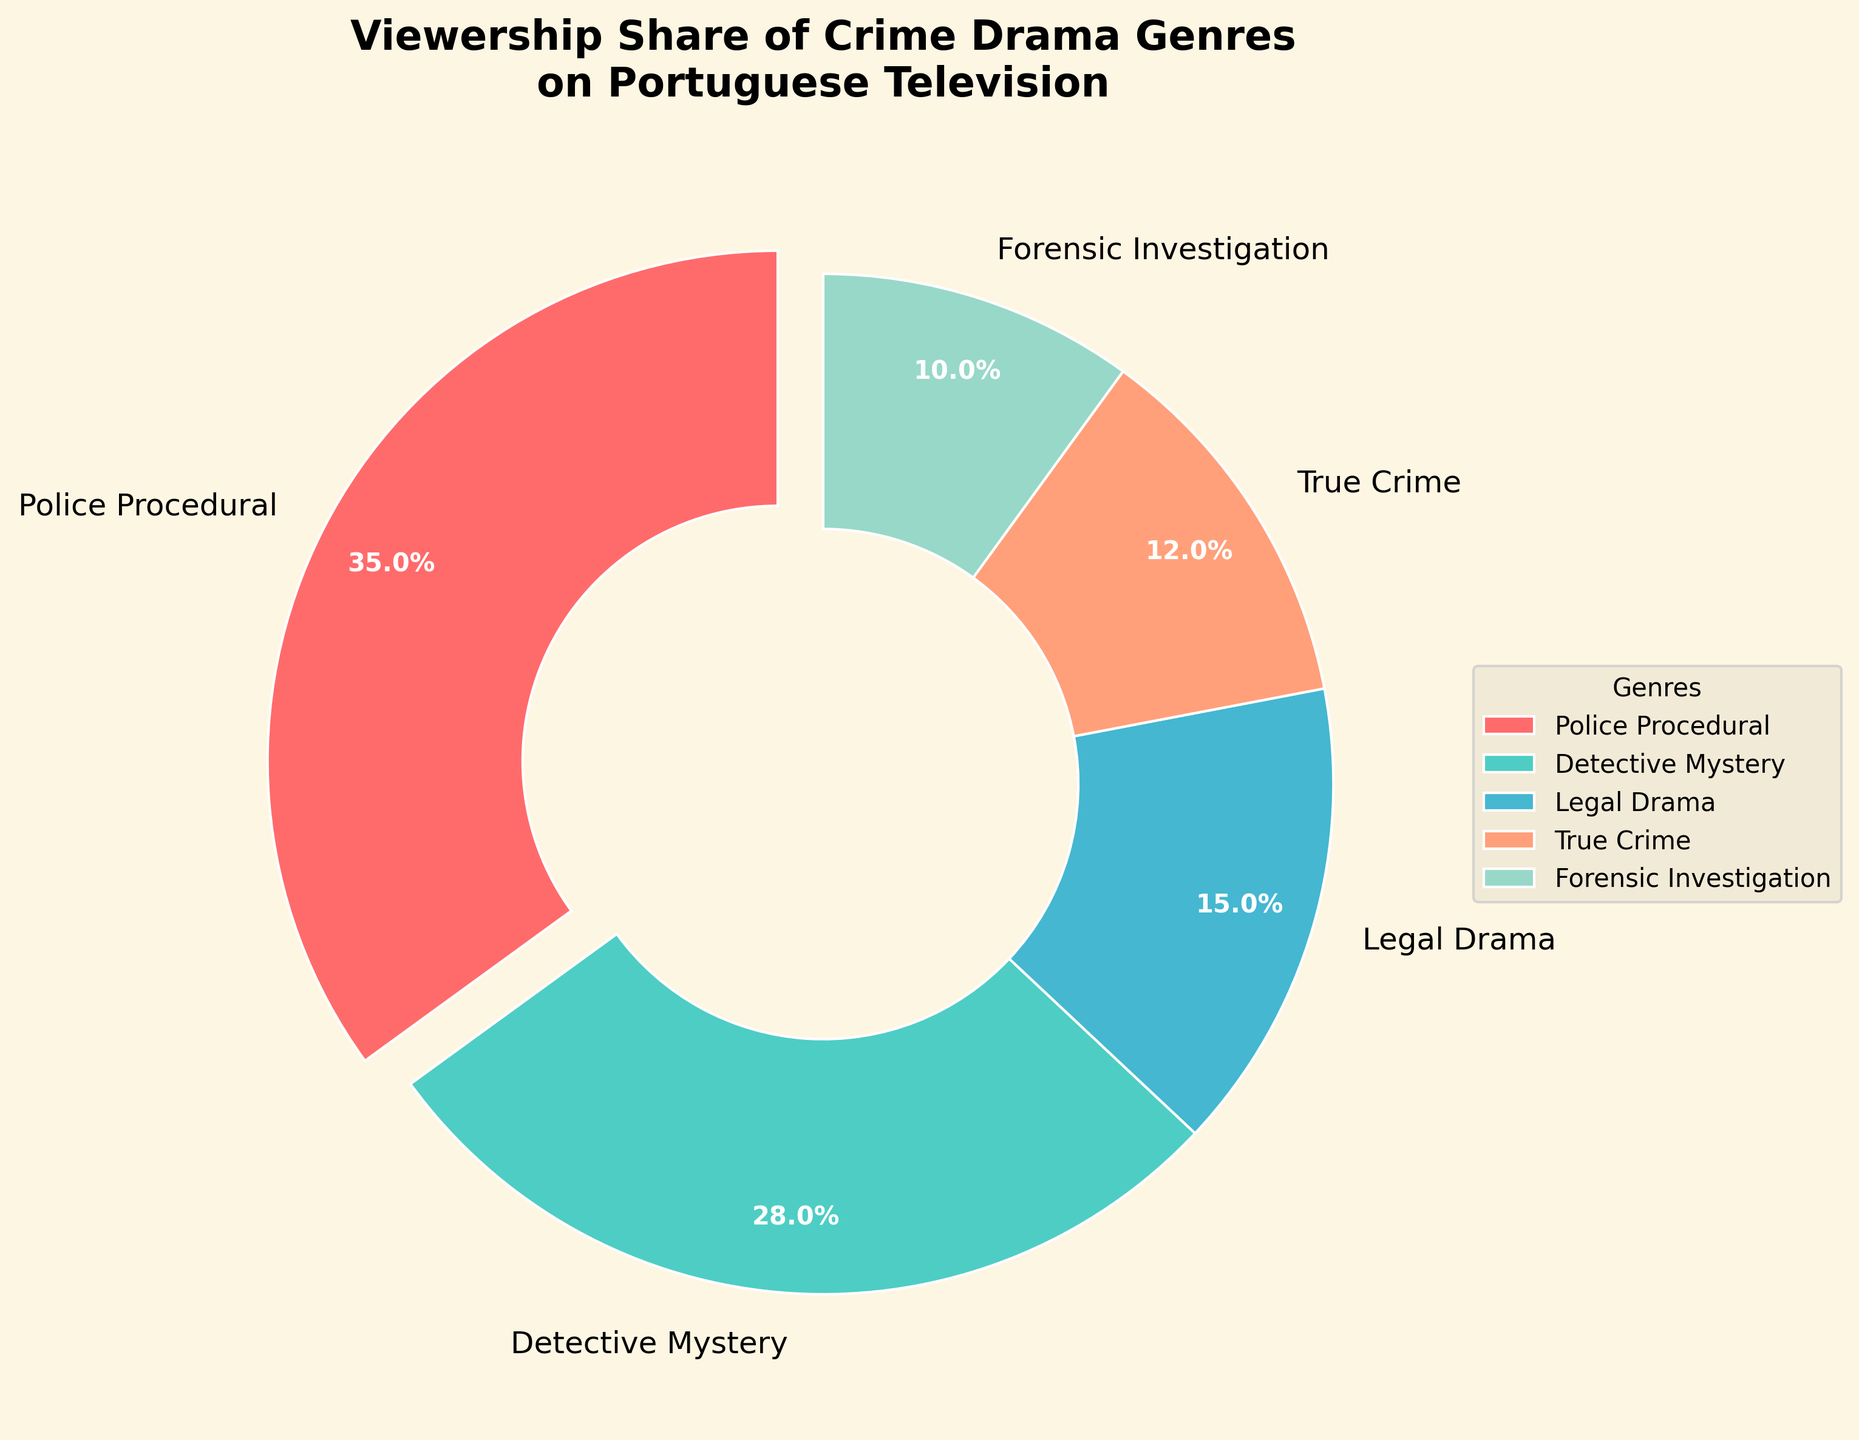what is the title of the plot? The title of the plot is stated at the top of the figure. It provides an overview of what the plot represents. The title is "Viewership Share of Crime Drama Genres on Portuguese Television".
Answer: Viewership Share of Crime Drama Genres on Portuguese Television Which genre has the highest viewership share? By examining the pie chart, the segment with the largest portion corresponds to "Police Procedural".
Answer: Police Procedural What is the viewership share of Forensic Investigation? The viewership share can be identified by the percentage label on the pie segment labeled "Forensic Investigation", which is 10%.
Answer: 10% Compare the viewership share of Police Procedural and Detective Mystery. Which one is higher and by how much? Police Procedural has a viewership share of 35%, and Detective Mystery has 28%. The difference is 35% - 28%, which is 7%.
Answer: Police Procedural by 7% What is the combined viewership share of Legal Drama and True Crime? The viewership shares of Legal Drama and True Crime are 15% and 12%, respectively. Adding them together gives 15% + 12% = 27%.
Answer: 27% What is the smallest viewership share among the genres? By identifying the smallest percentage label in the pie chart, which is Forensic Investigation with 10%.
Answer: 10% If a new genre were added and it took 5% from the Police Procedural's share, what would be the new share for Police Procedural? Police Procedural currently has 35%. If 5% is taken away, the new share would be 35% - 5% = 30%.
Answer: 30% Arrange the genres in descending order of their viewership share. Observing the pie chart segments: Police Procedural (35%), Detective Mystery (28%), Legal Drama (15%), True Crime (12%), Forensic Investigation (10%). Arranging them from highest to lowest gives: Police Procedural, Detective Mystery, Legal Drama, True Crime, Forensic Investigation.
Answer: Police Procedural, Detective Mystery, Legal Drama, True Crime, Forensic Investigation 